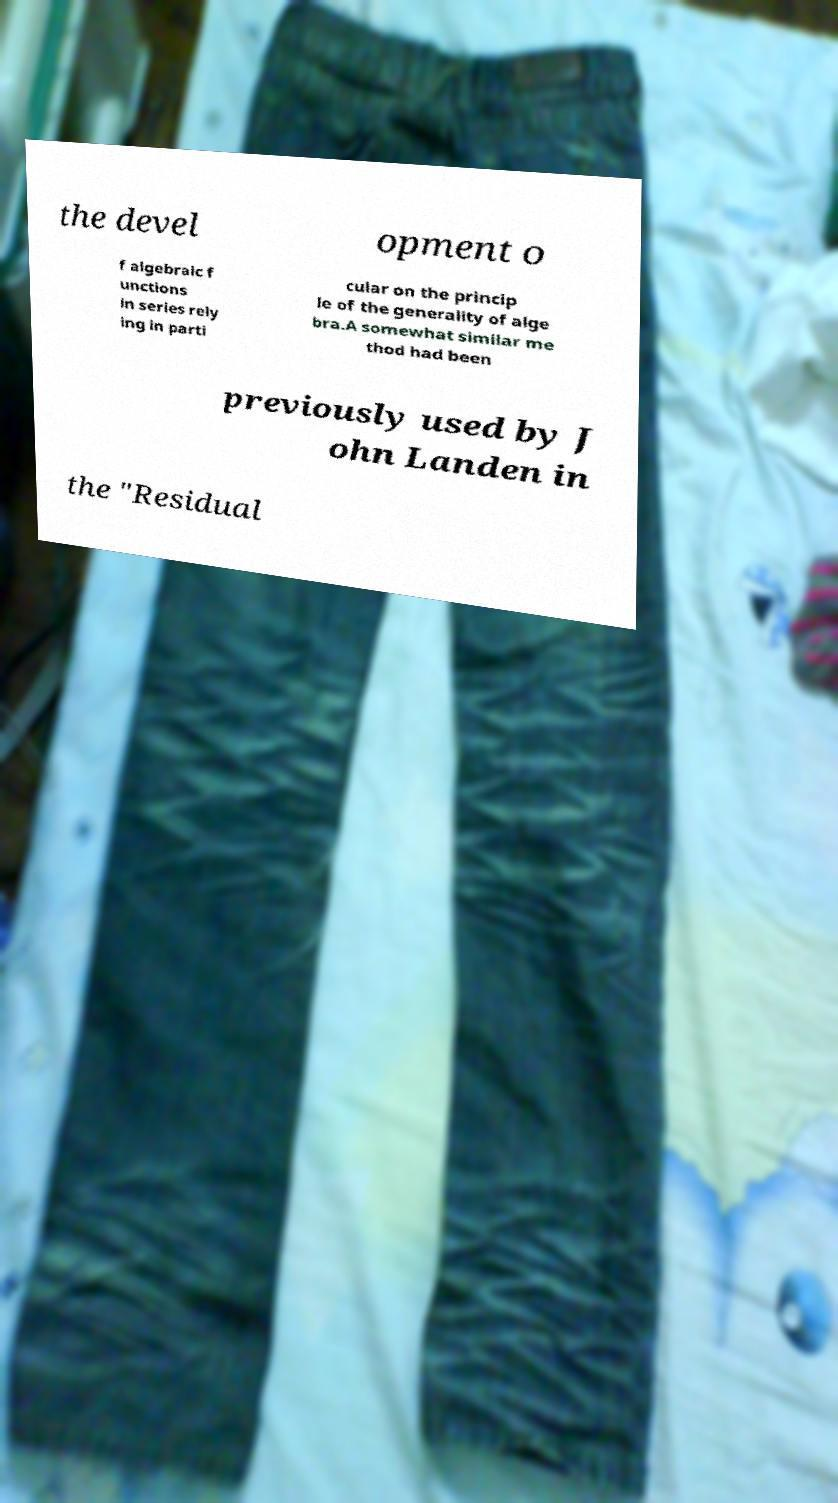Could you extract and type out the text from this image? the devel opment o f algebraic f unctions in series rely ing in parti cular on the princip le of the generality of alge bra.A somewhat similar me thod had been previously used by J ohn Landen in the "Residual 